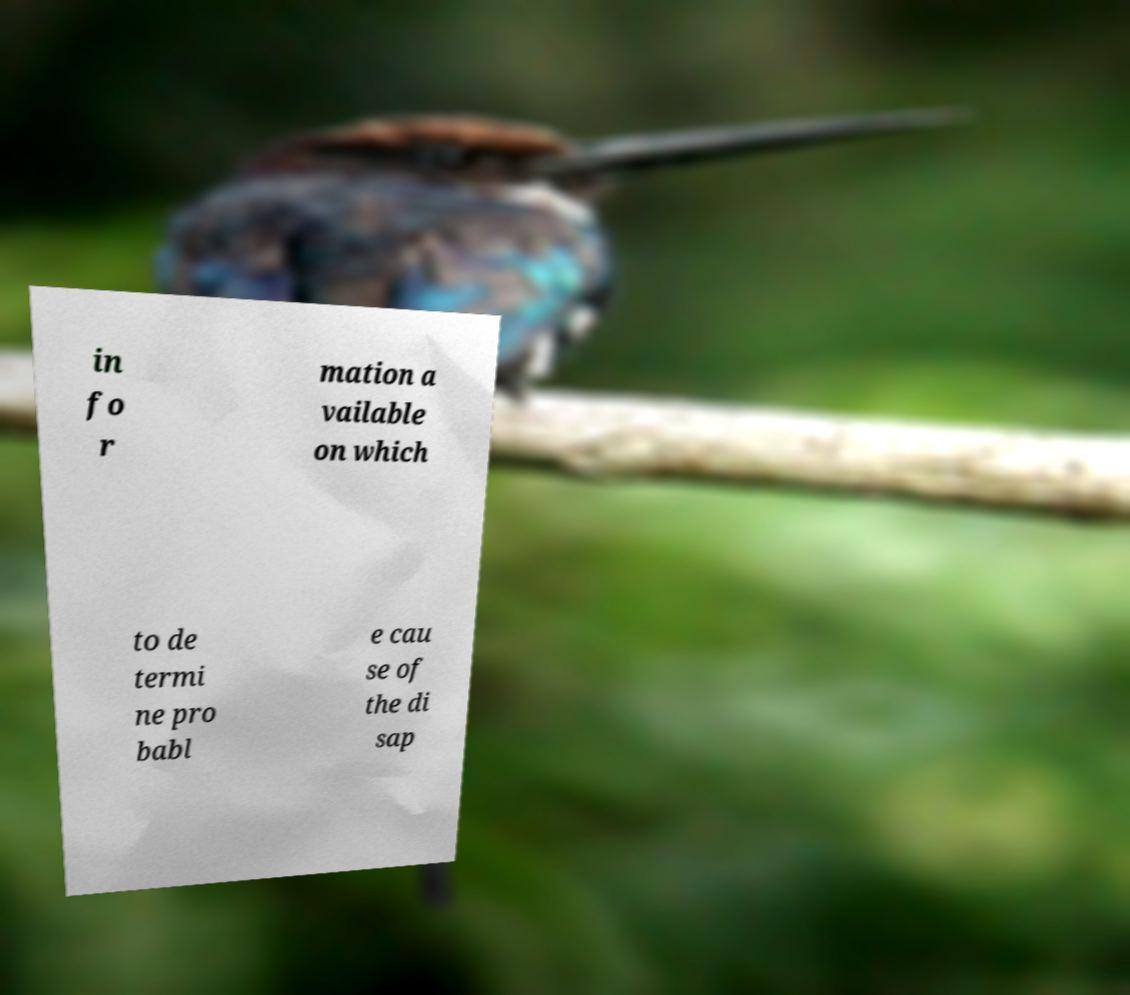There's text embedded in this image that I need extracted. Can you transcribe it verbatim? in fo r mation a vailable on which to de termi ne pro babl e cau se of the di sap 